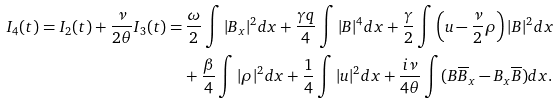Convert formula to latex. <formula><loc_0><loc_0><loc_500><loc_500>I _ { 4 } ( t ) = I _ { 2 } ( t ) + \frac { \nu } { 2 \theta } I _ { 3 } ( t ) = & \, \frac { \omega } { 2 } \int | B _ { x } | ^ { 2 } d x + \frac { \gamma q } { 4 } \int | B | ^ { 4 } d x + \frac { \gamma } { 2 } \int \left ( u - \frac { \nu } { 2 } \rho \right ) | B | ^ { 2 } d x \\ & + \frac { \beta } { 4 } \int | \rho | ^ { 2 } d x + \frac { 1 } { 4 } \int | u | ^ { 2 } d x + \frac { i \nu } { 4 \theta } \int ( B \overline { B } _ { x } - B _ { x } \overline { B } ) d x .</formula> 